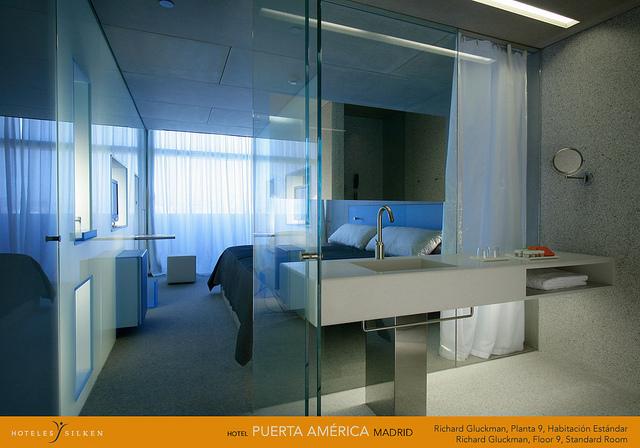Can you see the towels?
Concise answer only. Yes. What color are the curtains on the end?
Short answer required. White. What is the color of the bedding?
Concise answer only. Black. What color is the bedspread?
Quick response, please. Black. Is the sink faucet turned on?
Answer briefly. No. 